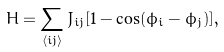Convert formula to latex. <formula><loc_0><loc_0><loc_500><loc_500>H = \sum _ { \langle i j \rangle } J _ { i j } [ 1 - \cos ( \phi _ { i } - \phi _ { j } ) ] ,</formula> 